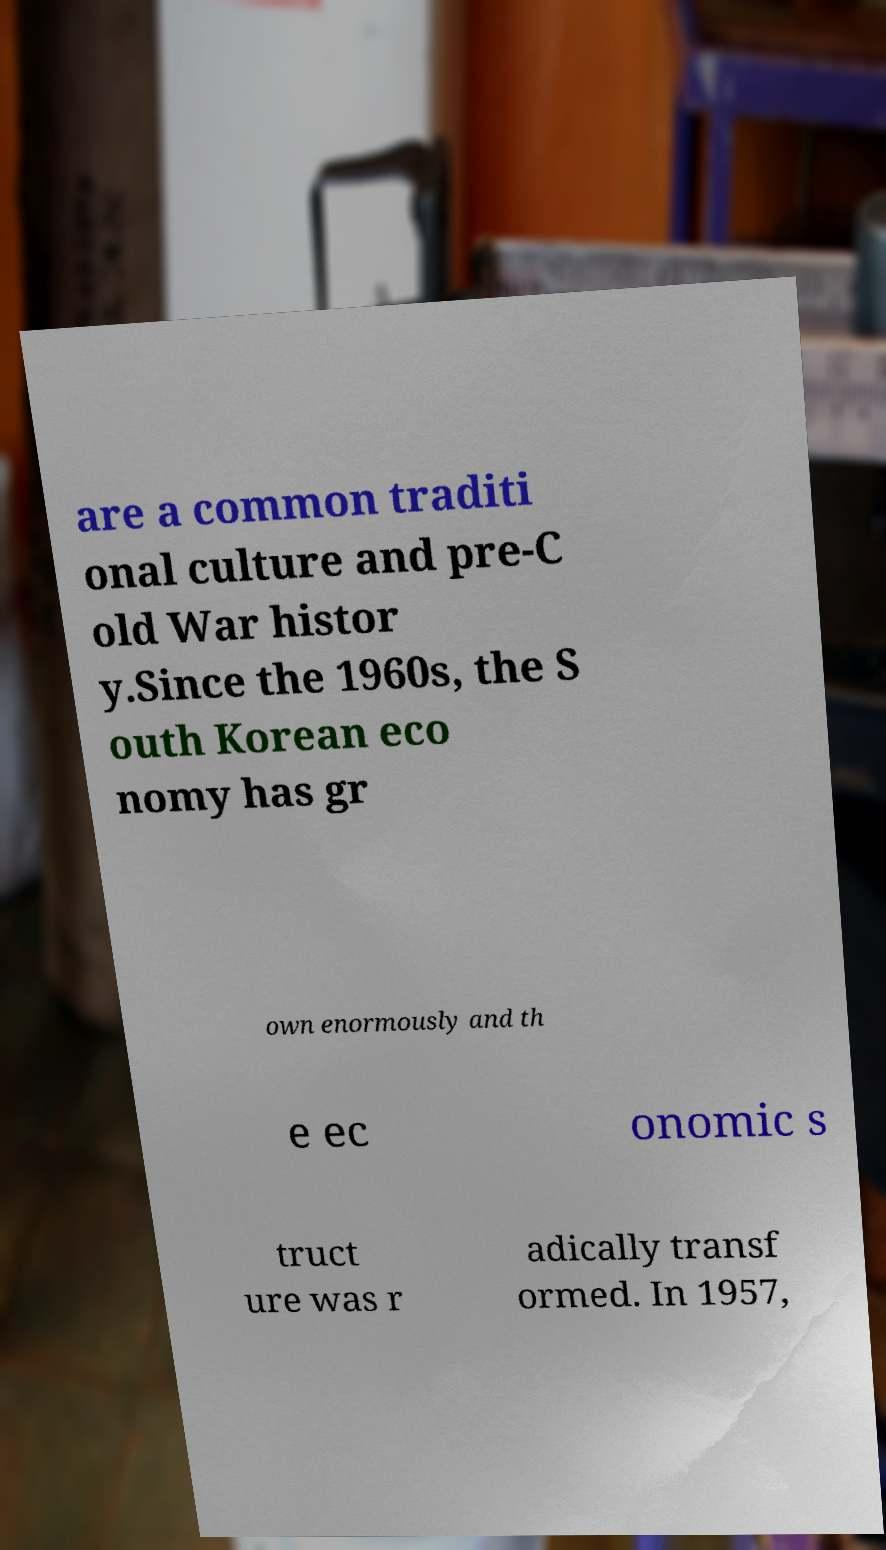There's text embedded in this image that I need extracted. Can you transcribe it verbatim? are a common traditi onal culture and pre-C old War histor y.Since the 1960s, the S outh Korean eco nomy has gr own enormously and th e ec onomic s truct ure was r adically transf ormed. In 1957, 